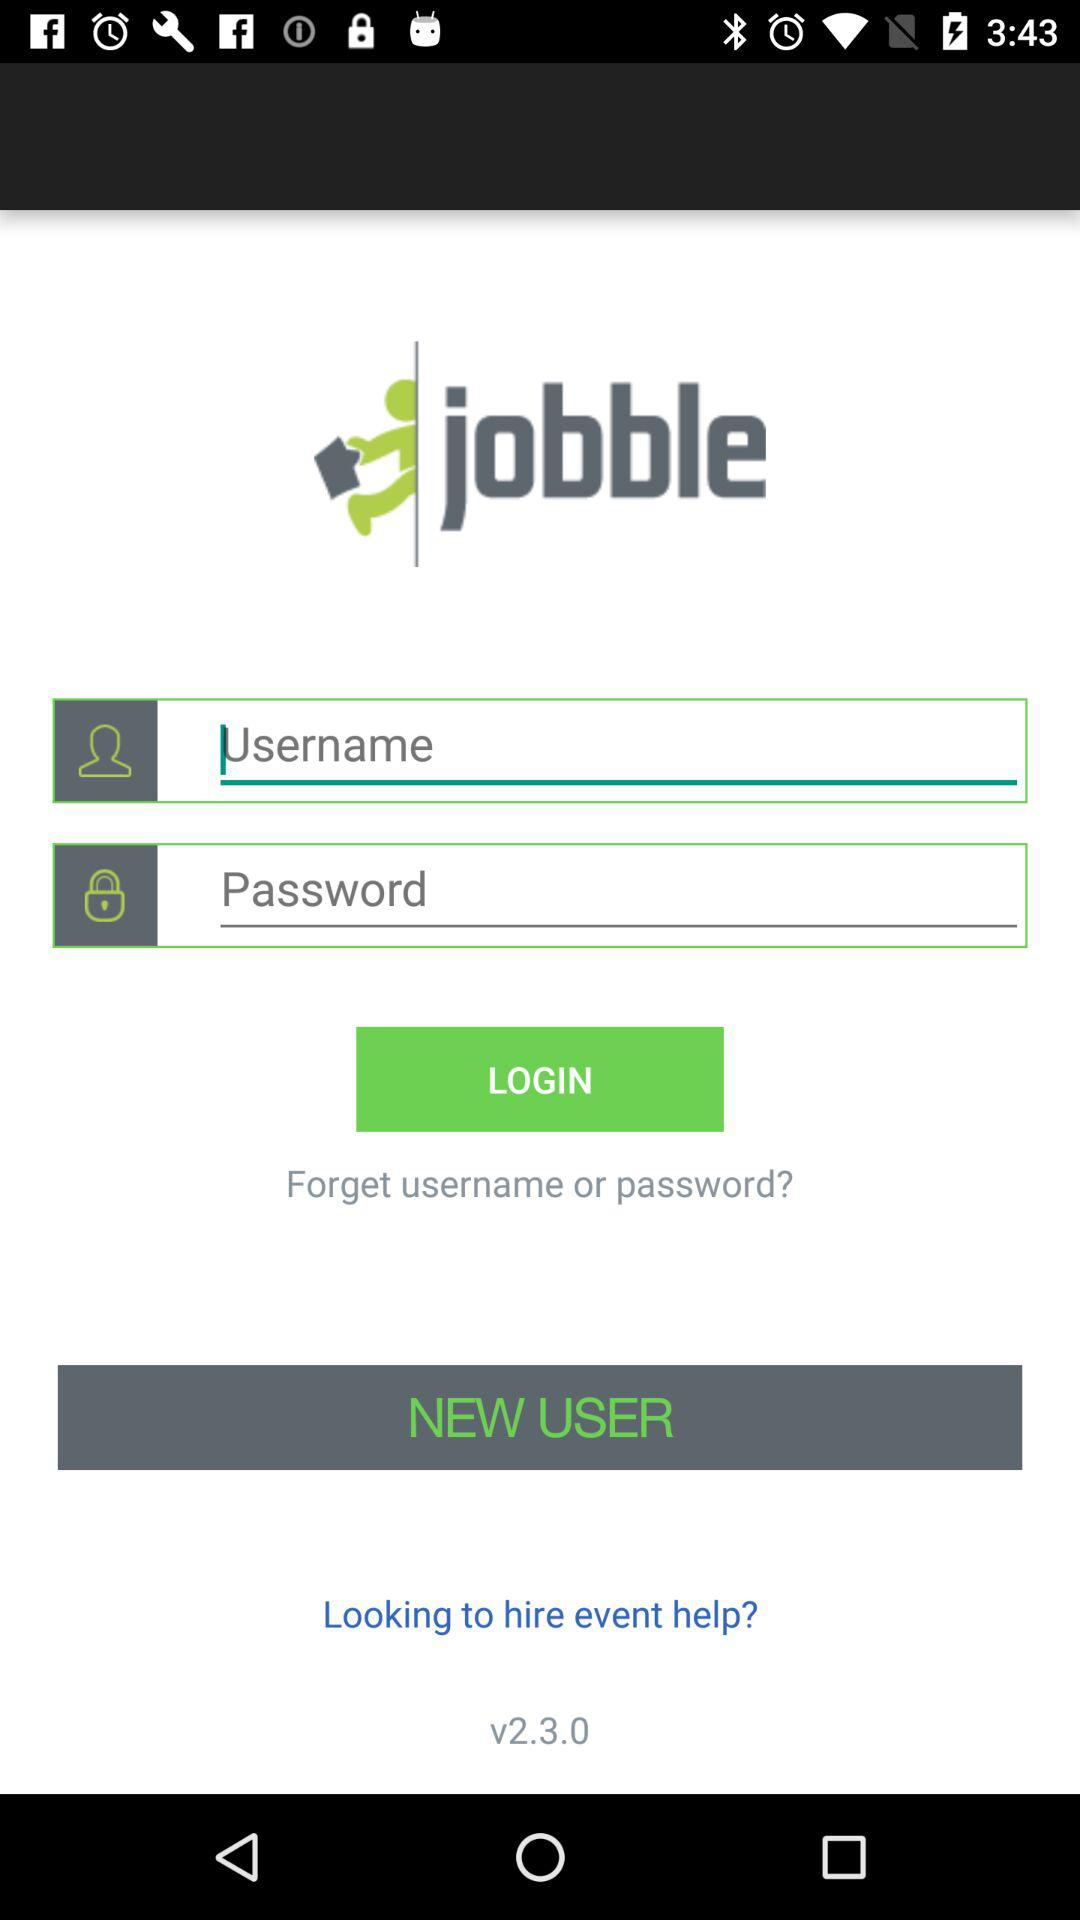What is the version? The version is v2.3.0. 